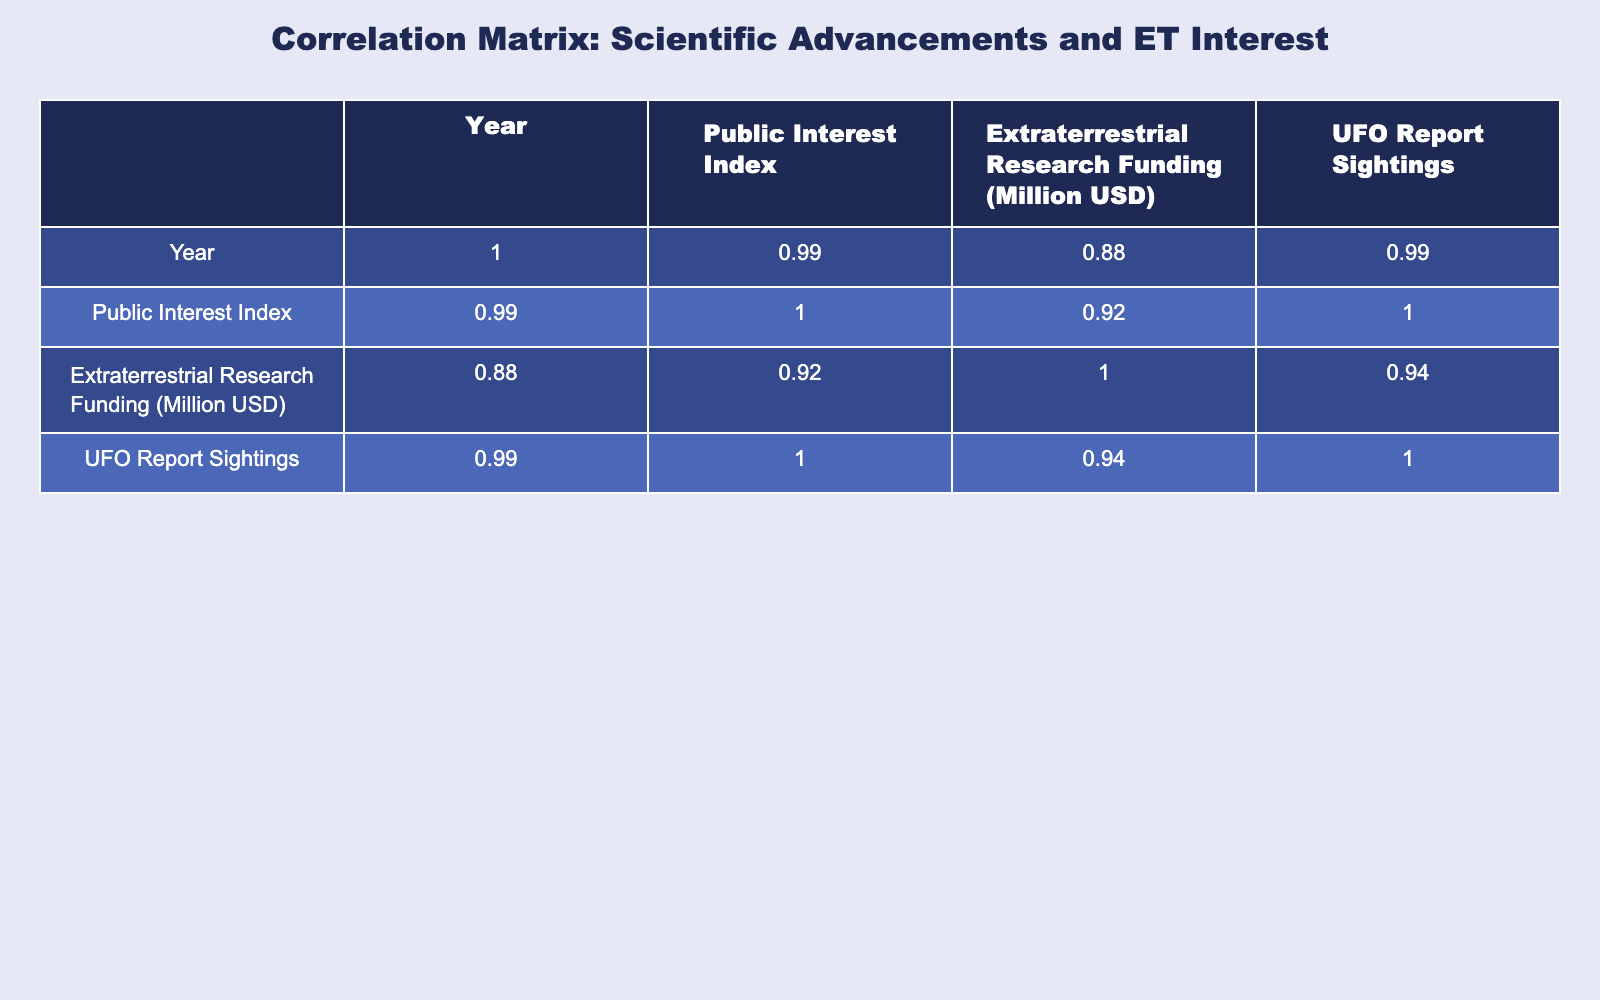What was the Public Interest Index in the year 2000? Referring to the table, the Public Interest Index for the year 2000 is listed directly as 45.
Answer: 45 What was the value of Extraterrestrial Research Funding in 2015? Looking at the table, the funding for Extraterrestrial Research in the year 2015 is shown as 30 million USD.
Answer: 30 million USD Is there a correlation between the Scientific Advancement in 2020 and UFO Report Sightings? From the table, the Scientific Advancement in 2020 is the launch of the Mars 2020 Perseverance Rover with UFO Report Sightings at 1200. This indicates a relationship, but detailed correlation is difficult to measure with just one data point. Thus, we cannot definitively conclude correlation without further analysis.
Answer: No What is the average Public Interest Index from 2000 to 2023? The Public Interest Index values from 2000 to 2023 are 45, 55, 60, 70, 80, and 90. Adding these gives 400, and dividing by 6 (number of data points) results in an average of 66.67.
Answer: 66.67 Which year had the highest Extraterrestrial Research Funding? By examining the table, it is clear that the year 2023 had the highest funding at 150 million USD, compared to other years listed.
Answer: 2023 Did the detection of phosphine in Venus' atmosphere in 2015 result in a higher Public Interest Index than the launch of the Chandra X-ray Observatory in 2000? The Public Interest Index for 2015 is 70 while it was 45 for 2000, thus the detection of phosphine did indeed result in a higher index.
Answer: Yes What is the difference in UFO Report Sightings between 2010 and 2023? In 2010, there were 700 UFO Report Sightings and in 2023 there were 1400. The difference is calculated as 1400 - 700 = 700 sightings.
Answer: 700 sightings What year had a Public Interest Index lower than 60? By evaluating the table, the year 2000 has a Public Interest Index of 45, which is lower than 60. Thus, this is the only year fitting this criterion.
Answer: 2000 How many million USD was the Extraterrestrial Research Funding in 2005 and 2010 combined? The funding in 2005 was 25 million USD and in 2010 was 50 million USD. Combining these gives a total of 25 + 50 = 75 million USD.
Answer: 75 million USD 